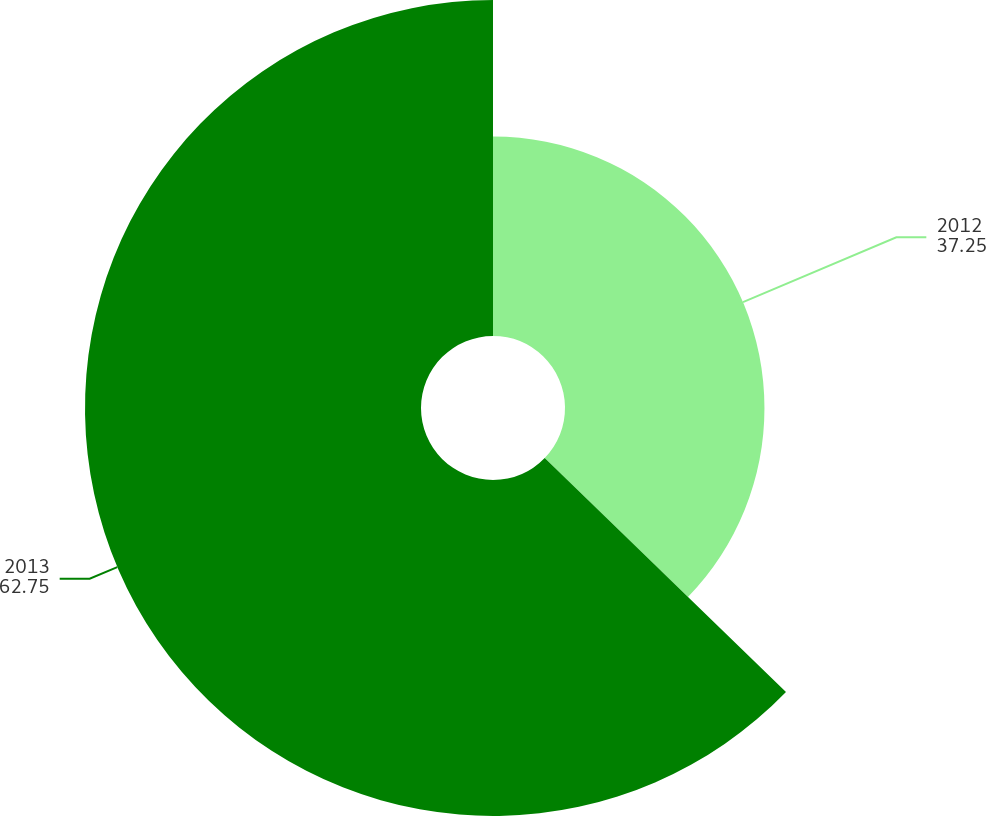<chart> <loc_0><loc_0><loc_500><loc_500><pie_chart><fcel>2012<fcel>2013<nl><fcel>37.25%<fcel>62.75%<nl></chart> 